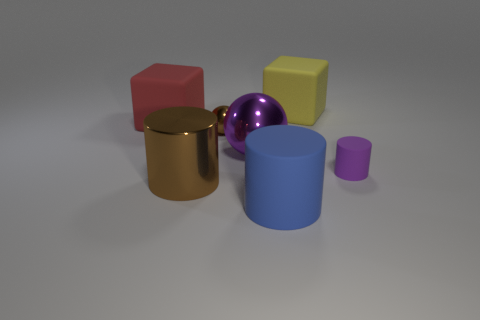Subtract all blue spheres. Subtract all cyan cylinders. How many spheres are left? 2 Add 1 large yellow balls. How many objects exist? 8 Subtract all cylinders. How many objects are left? 4 Add 2 purple rubber cylinders. How many purple rubber cylinders are left? 3 Add 3 yellow objects. How many yellow objects exist? 4 Subtract 0 blue spheres. How many objects are left? 7 Subtract all large blue things. Subtract all big rubber cylinders. How many objects are left? 5 